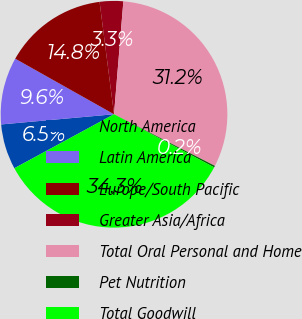<chart> <loc_0><loc_0><loc_500><loc_500><pie_chart><fcel>North America<fcel>Latin America<fcel>Europe/South Pacific<fcel>Greater Asia/Africa<fcel>Total Oral Personal and Home<fcel>Pet Nutrition<fcel>Total Goodwill<nl><fcel>6.47%<fcel>9.59%<fcel>14.81%<fcel>3.35%<fcel>31.22%<fcel>0.23%<fcel>34.34%<nl></chart> 